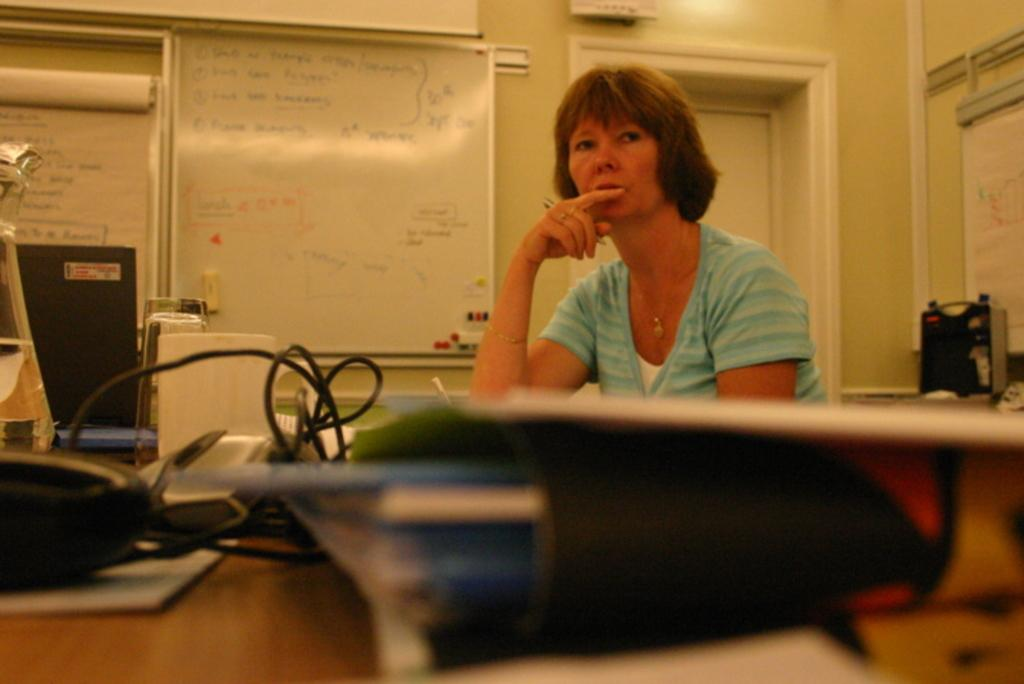What is the person in the image wearing? The person is wearing a white and blue dress in the image. What can be seen on the table in the image? There are wires, files, and other objects on the table in the image. What is visible on the wall in the background of the image? There are boards on the wall in the background of the image. What type of error can be seen on the board in the image? There is no error visible on the board in the image. What type of curve is present in the image? There is no curve present in the image. 